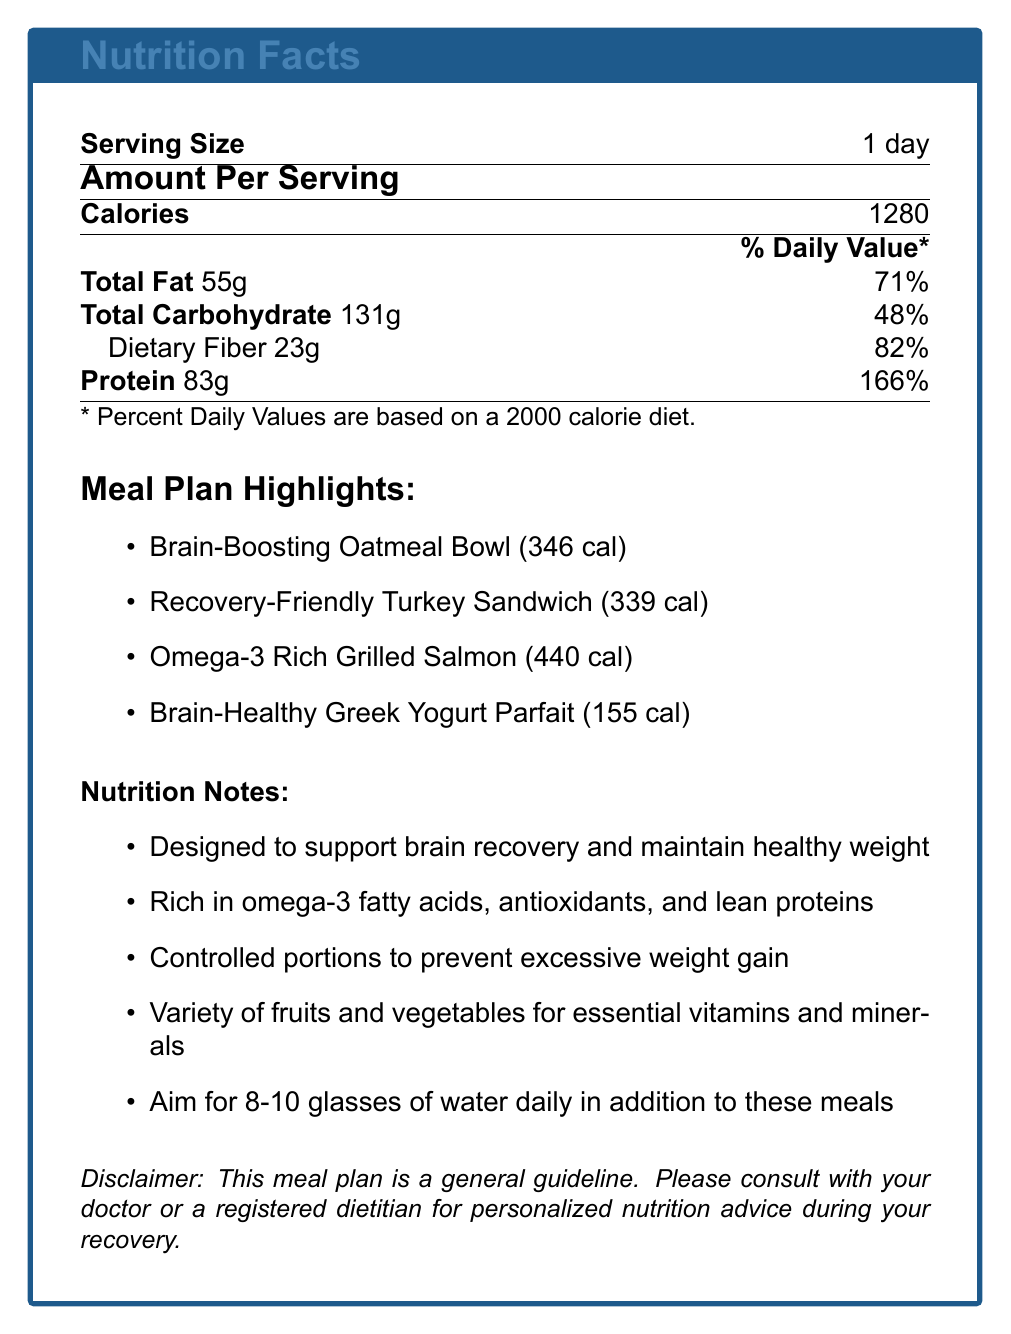what is the total number of calories for the day? The document clearly states that the total number of calories for the day is 1280.
Answer: 1280 how much protein is in the Brain-Boosting Oatmeal Bowl? The document indicates that the Brain-Boosting Oatmeal Bowl contains 13 grams of protein.
Answer: 13 grams which meal has the highest calorie count? By examining the total calories for each meal listed, the Omega-3 Rich Grilled Salmon has the highest calorie count at 440 calories.
Answer: Omega-3 Rich Grilled Salmon what is the dietary fiber content of the Recovery-Friendly Turkey Sandwich? The document shows that the Recovery-Friendly Turkey Sandwich contains 8 grams of dietary fiber.
Answer: 8 grams how many glasses of water should you aim to drink daily? The nutrition notes suggest aiming for 8-10 glasses of water daily in addition to the meals provided.
Answer: 8-10 glasses which meal contains avocado? The list of ingredients for the Recovery-Friendly Turkey Sandwich includes avocado.
Answer: Recovery-Friendly Turkey Sandwich what is the total carbohydrate content for the day? A. 100g B. 131g C. 150g D. 200g The document states that the total carbohydrate content for the day is 131 grams.
Answer: B. 131g how many calories are in the Brain-Healthy Greek Yogurt Parfait? A. 120 B. 155 C. 200 D. 255 The Brain-Healthy Greek Yogurt Parfait has 155 calories according to the document.
Answer: B. 155 is this meal plan intended to support brain recovery? The nutrition notes mention that the meal plan is designed to support brain recovery.
Answer: Yes describe the main idea of the document. The document outlines a meal plan including breakfast, lunch, dinner, and a snack. Each meal's calorie count and nutritional values are provided. It emphasizes brain recovery, controlled portions, and adequate hydration.
Answer: The document provides a calorie-controlled meal plan designed to support brain recovery and maintain a healthy weight during rehabilitation. It includes specific meals with their nutritional breakdowns, total daily nutrition facts, and additional nutrition notes emphasizing controlled portions, essential nutrients, and hydration. how much fat does the Omega-3 Rich Grilled Salmon contain? According to the document, the Omega-3 Rich Grilled Salmon contains 22 grams of fat.
Answer: 22 grams how many types of fruits and vegetables are incorporated in the meal plan? The document mentions a variety of fruits and vegetables but does not specify the exact types included in the meal plan.
Answer: Not enough information what is the purpose of this meal plan? The document explicitly states that the meal plan is designed to support brain recovery and maintain a healthy weight during rehabilitation.
Answer: To support brain recovery and maintain a healthy weight during rehabilitation. 